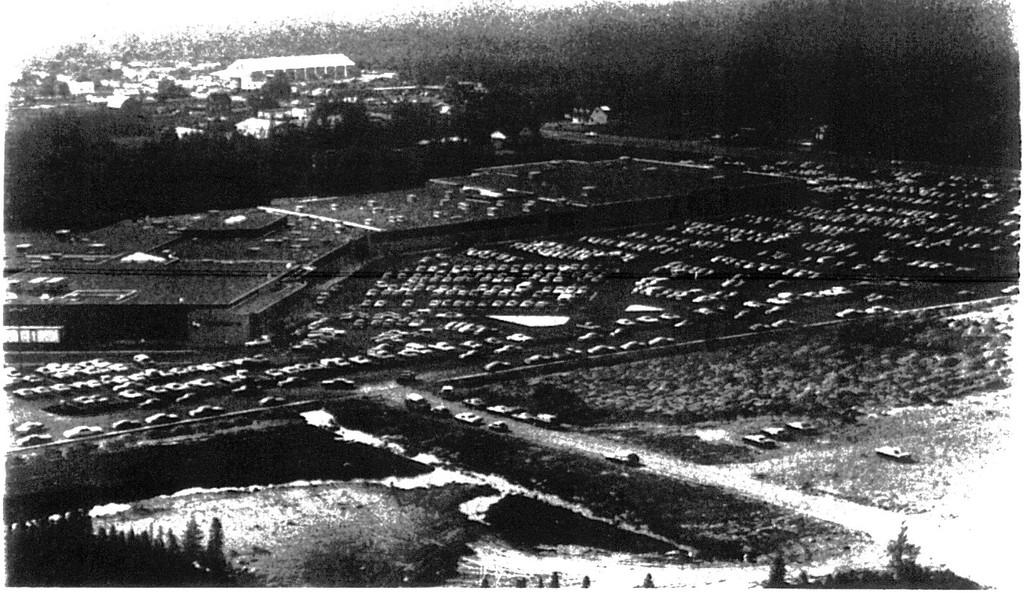What can be seen in the parking place in the image? There are cars parked in a parking place in the image. What is visible in the background of the image? There are buildings and trees in the background of the image. What type of pets can be seen playing with a skate in the image? There are no pets or skates present in the image. Can you hear the people in the image laughing? There is no indication of sound or laughter in the image, as it is a still photograph. 